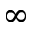<formula> <loc_0><loc_0><loc_500><loc_500>\infty</formula> 